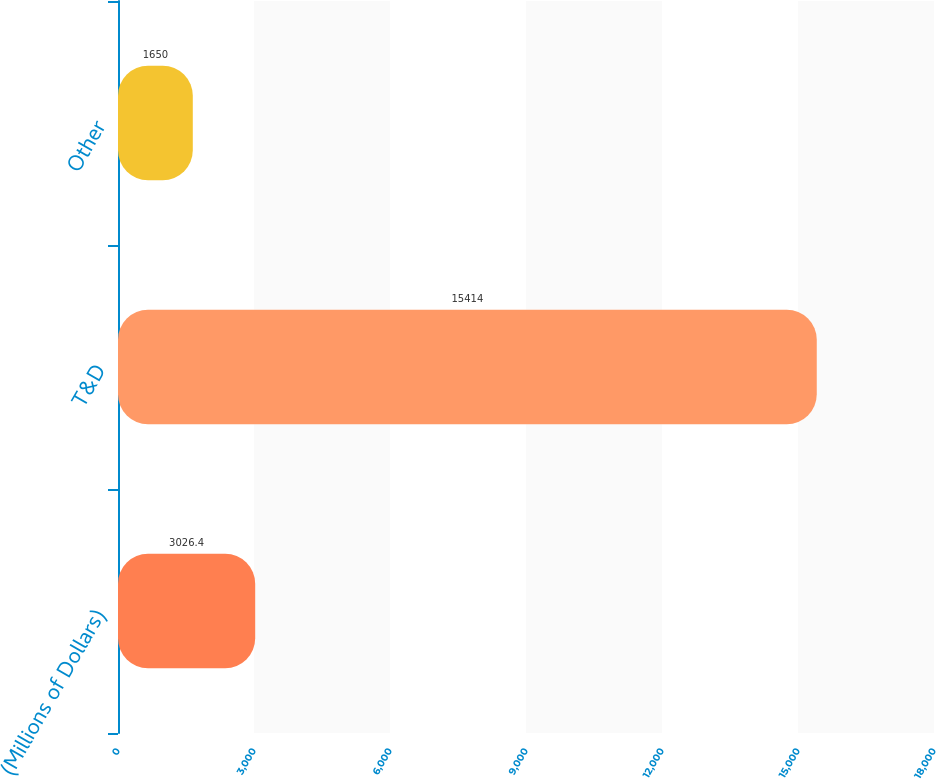<chart> <loc_0><loc_0><loc_500><loc_500><bar_chart><fcel>(Millions of Dollars)<fcel>T&D<fcel>Other<nl><fcel>3026.4<fcel>15414<fcel>1650<nl></chart> 